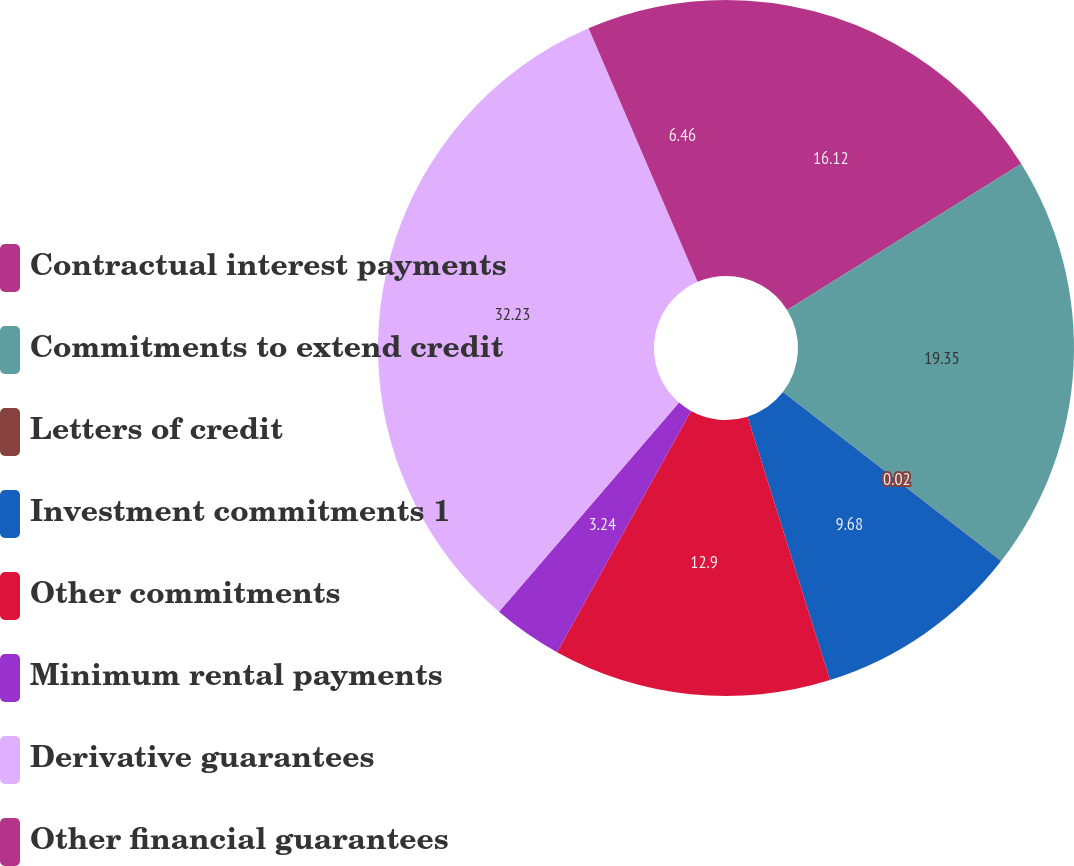<chart> <loc_0><loc_0><loc_500><loc_500><pie_chart><fcel>Contractual interest payments<fcel>Commitments to extend credit<fcel>Letters of credit<fcel>Investment commitments 1<fcel>Other commitments<fcel>Minimum rental payments<fcel>Derivative guarantees<fcel>Other financial guarantees<nl><fcel>16.12%<fcel>19.35%<fcel>0.02%<fcel>9.68%<fcel>12.9%<fcel>3.24%<fcel>32.23%<fcel>6.46%<nl></chart> 